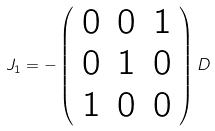Convert formula to latex. <formula><loc_0><loc_0><loc_500><loc_500>J _ { 1 } = - \left ( \begin{array} { c c c } { 0 } & { 0 } & { 1 } \\ { 0 } & { 1 } & { 0 } \\ { 1 } & { 0 } & { 0 } \end{array} \right ) D</formula> 